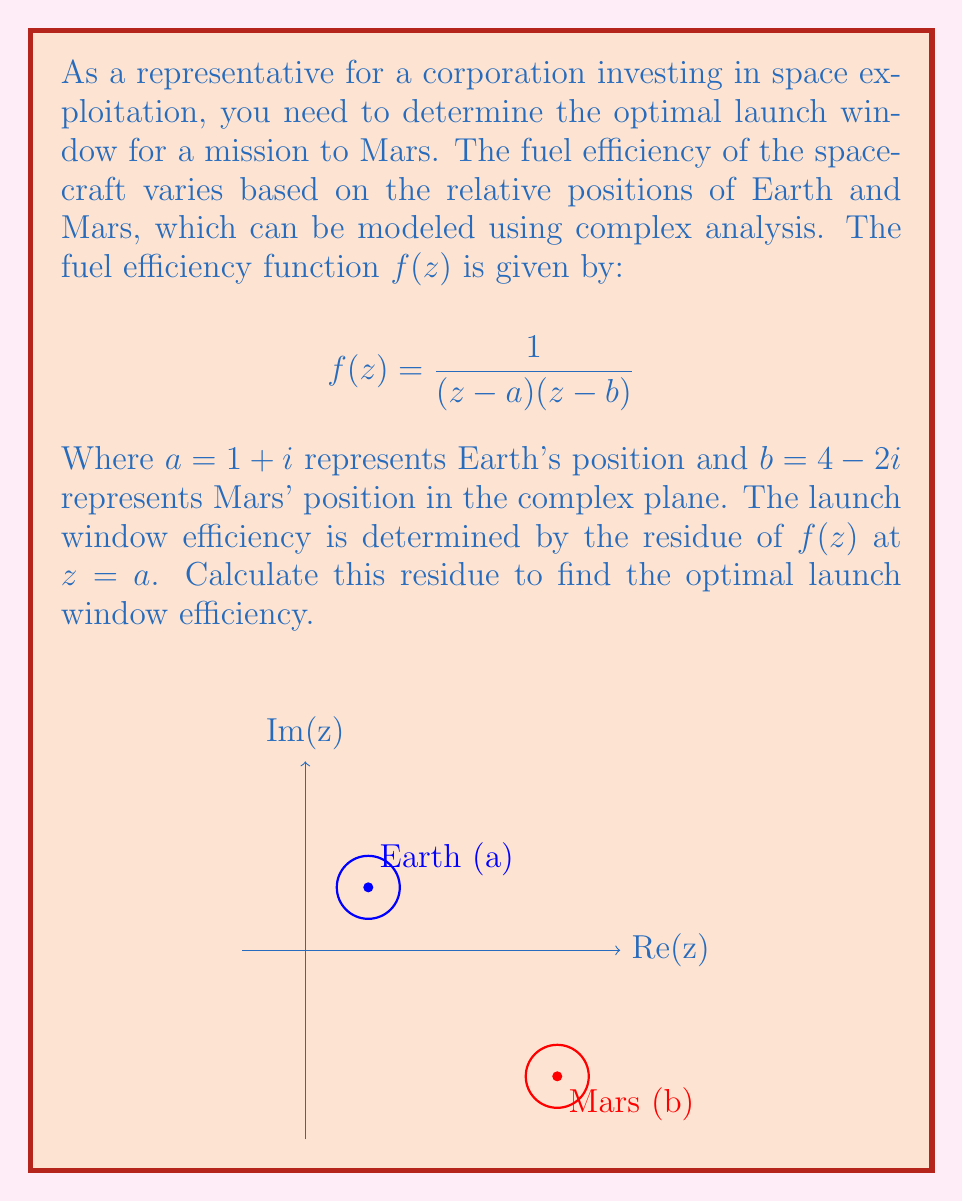Can you solve this math problem? To solve this problem, we'll use the residue theorem from complex analysis. The steps are as follows:

1) The residue of $f(z)$ at $z=a$ is given by:

   $$\text{Res}(f,a) = \lim_{z \to a} (z-a)f(z)$$

2) Substitute the given function:

   $$\text{Res}(f,a) = \lim_{z \to a} \frac{z-a}{(z-a)(z-b)}$$

3) Simplify:

   $$\text{Res}(f,a) = \lim_{z \to a} \frac{1}{z-b}$$

4) Evaluate the limit by substituting $z=a=1+i$:

   $$\text{Res}(f,a) = \frac{1}{(1+i)-(4-2i)} = \frac{1}{-3+3i}$$

5) Rationalize the denominator:

   $$\text{Res}(f,a) = \frac{1}{-3+3i} \cdot \frac{-3-3i}{-3-3i} = \frac{-3-3i}{18} = -\frac{1}{6} - \frac{1}{6}i$$

This complex number represents the optimal launch window efficiency.
Answer: $-\frac{1}{6} - \frac{1}{6}i$ 